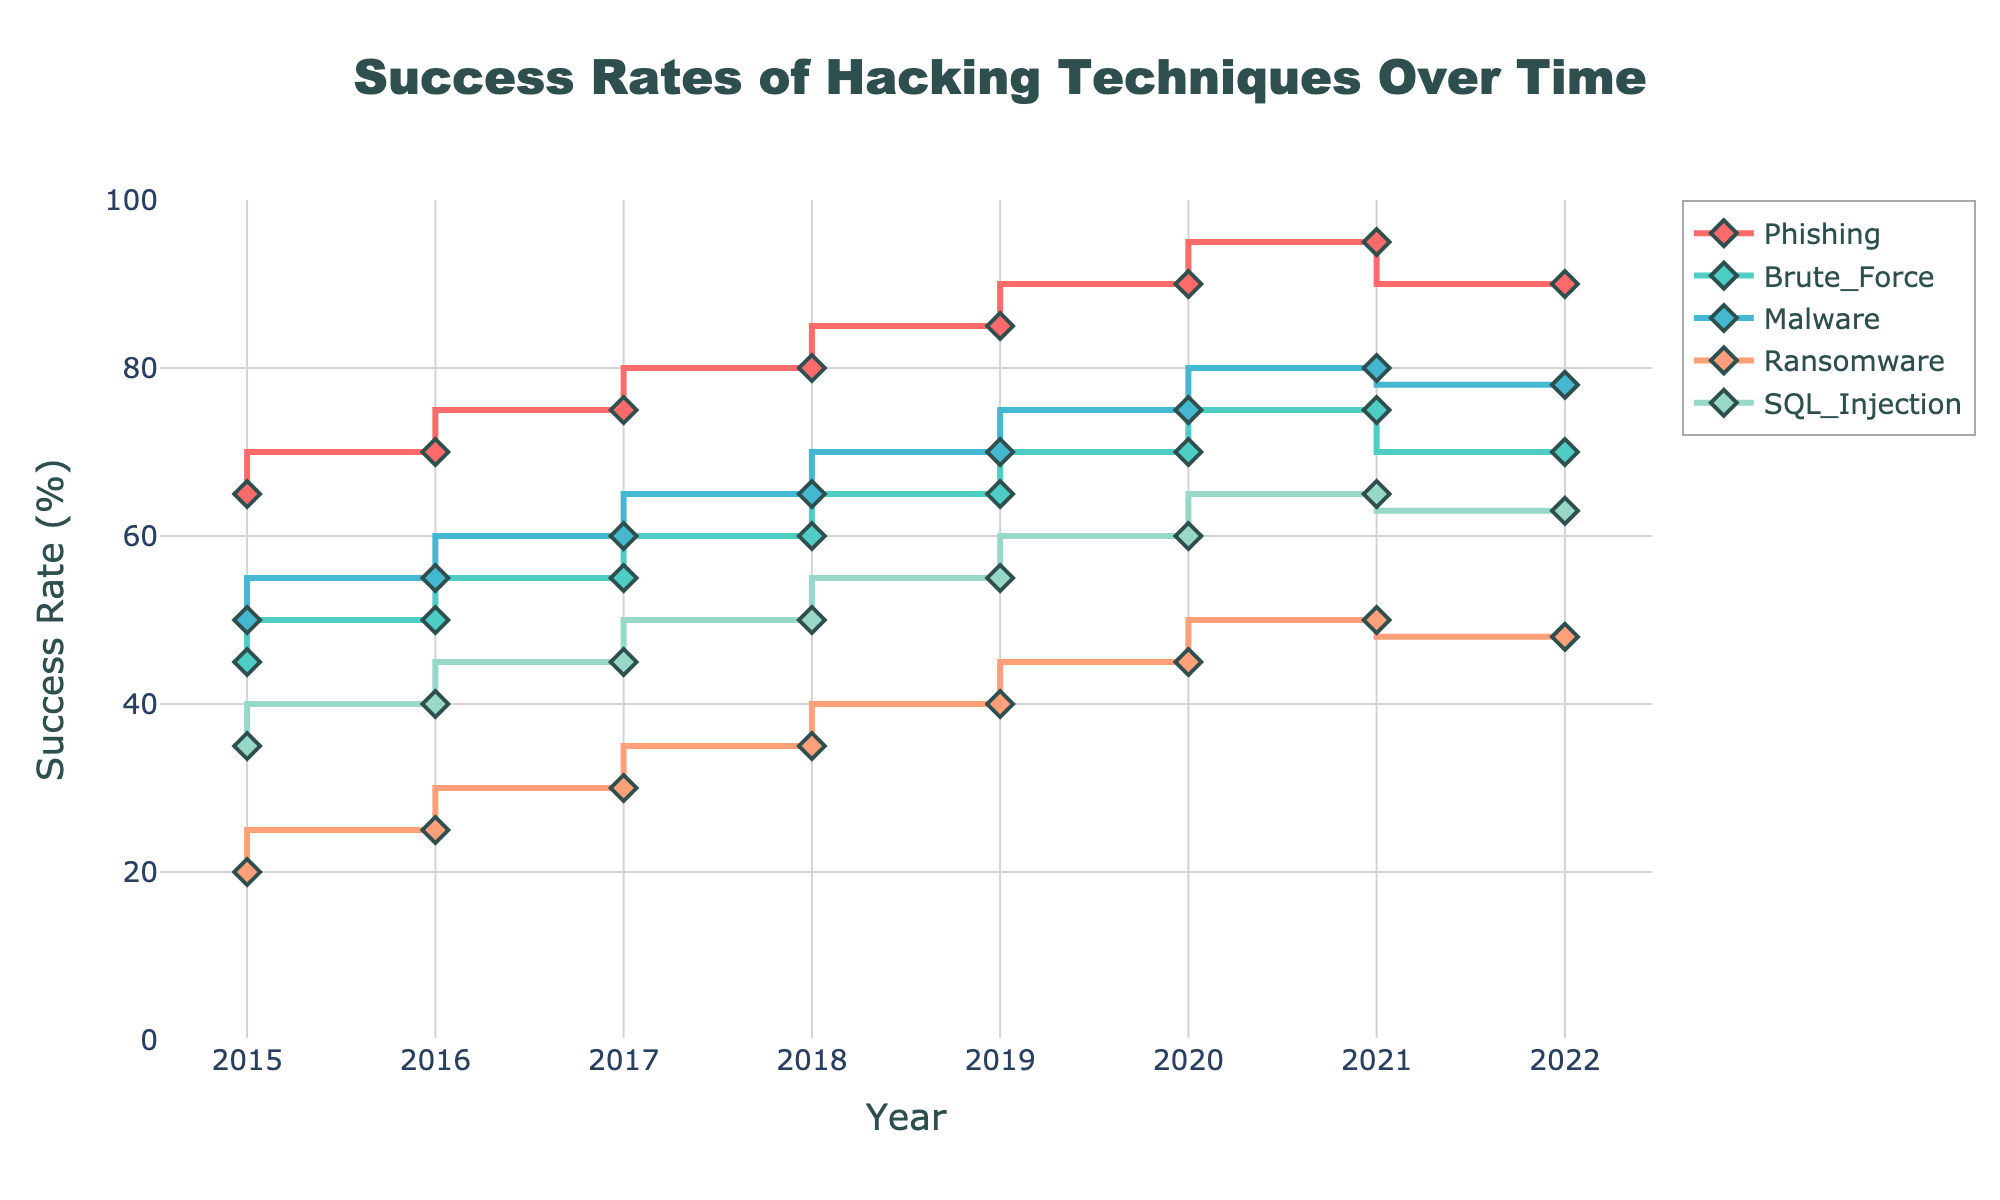What is the title of the figure? The title of the figure is displayed at the top and it indicates the main subject of the plot.
Answer: Success Rates of Hacking Techniques Over Time What is the highest success rate for phishing over the years? To find the highest success rate for phishing, locate the highest point on the line labeled "Phishing".
Answer: 95% in 2021 Which hacking technique had the lowest success rate in 2016? Look at the values for each technique in 2016 and pick the smallest number.
Answer: Ransomware (25%) By how much did the success rate of malware increase from 2015 to 2021? Subtract the malware success rate in 2015 from the rate in 2021: 80 - 50 = 30.
Answer: 30% Which technique had the highest average success rate from 2015 to 2022? Calculate the average success rate for each technique over the displayed years and compare them.
Answer: Phishing (over 80) Between which years did the success rate of ransomware see the greatest increase? Calculate the difference in success rate for ransomware between each consecutive year and identify the maximum difference.
Answer: Between 2017 and 2018 (5%) Which two techniques had nearly constant success rates between 2021 and 2022? Compare the success rates of each hacking technique between 2021 and 2022 and find those with minimal change.
Answer: Phishing and Brute Force What is the trend of SQL Injection technique over the years? Observe the overall shape and direction of the line representing SQL Injection from 2015 to 2022.
Answer: Increasing Which technique saw a decrease in success rate from 2021 to 2022? Identify which lines show a decline between the points for 2021 and 2022.
Answer: Phishing and Brute Force 